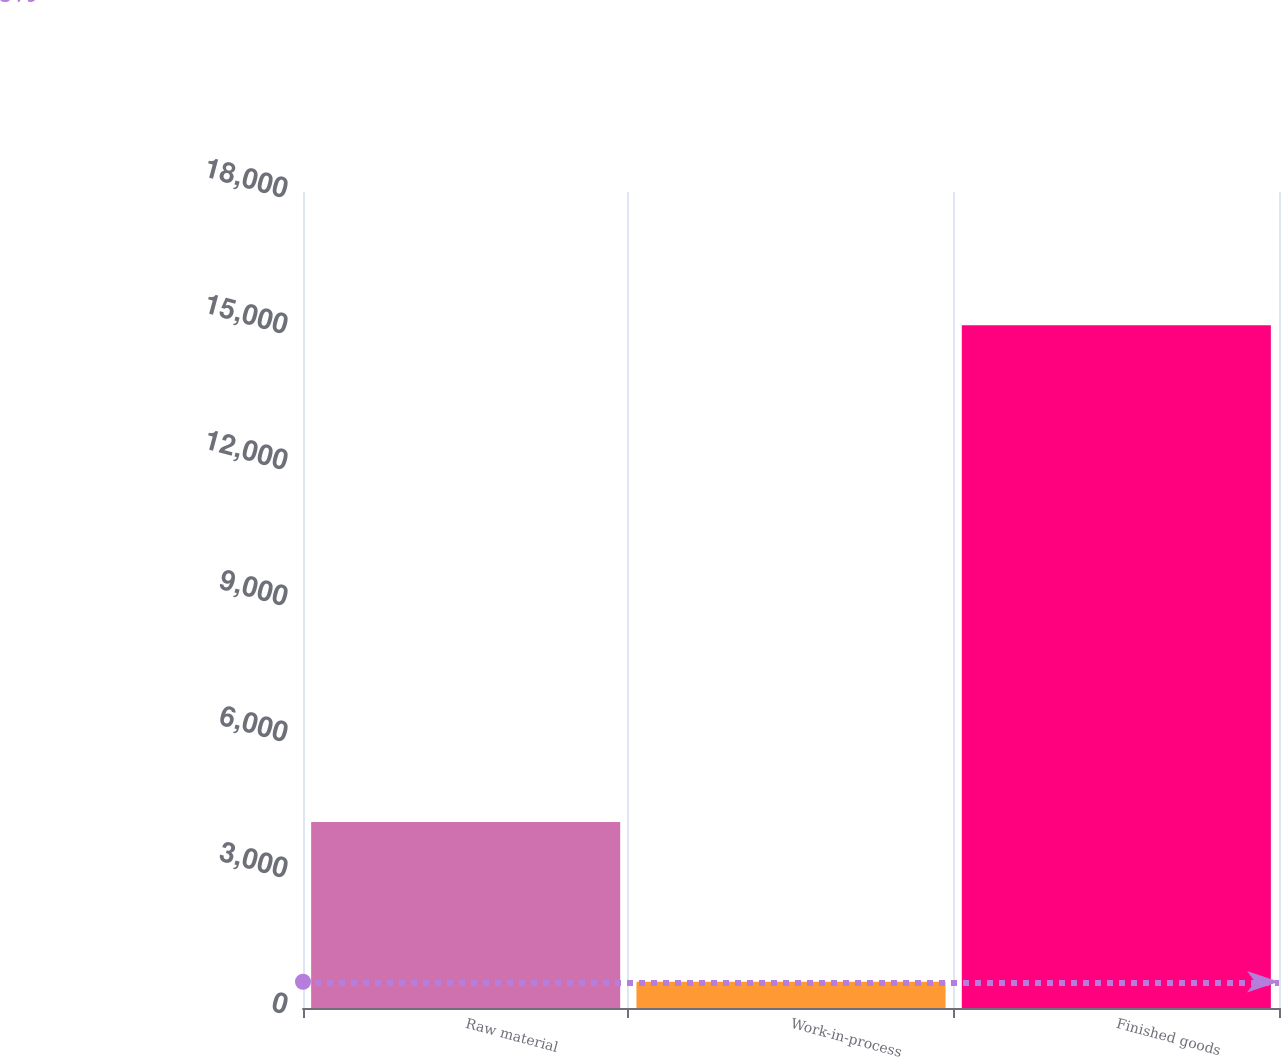Convert chart. <chart><loc_0><loc_0><loc_500><loc_500><bar_chart><fcel>Raw material<fcel>Work-in-process<fcel>Finished goods<nl><fcel>4102<fcel>579<fcel>15060<nl></chart> 